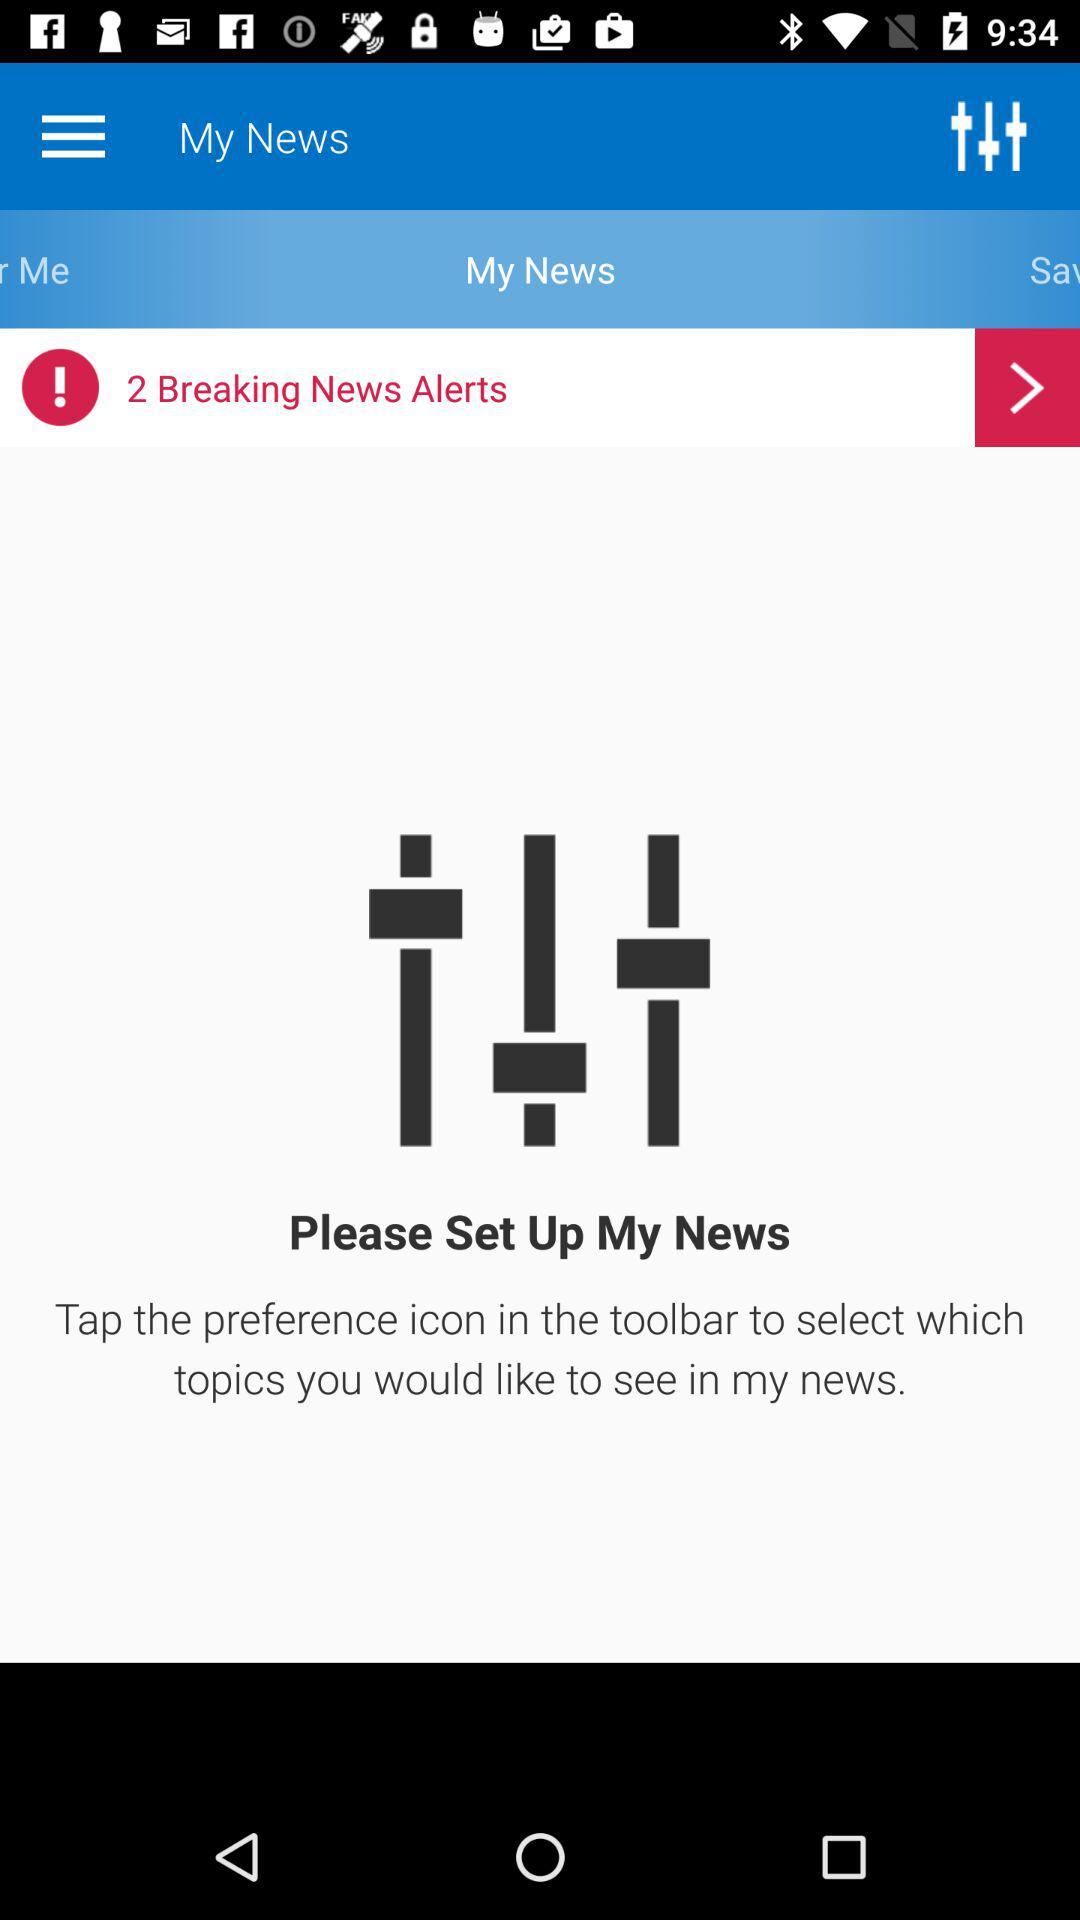What will happen when we tap the preference icon in the toolbar?
When the provided information is insufficient, respond with <no answer>. <no answer> 